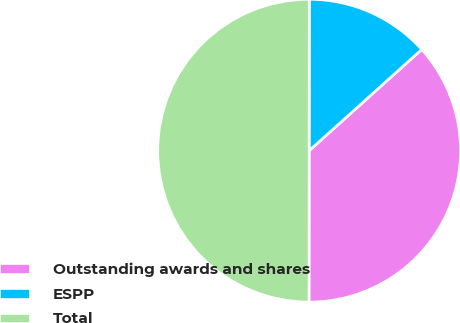Convert chart to OTSL. <chart><loc_0><loc_0><loc_500><loc_500><pie_chart><fcel>Outstanding awards and shares<fcel>ESPP<fcel>Total<nl><fcel>36.67%<fcel>13.33%<fcel>50.0%<nl></chart> 